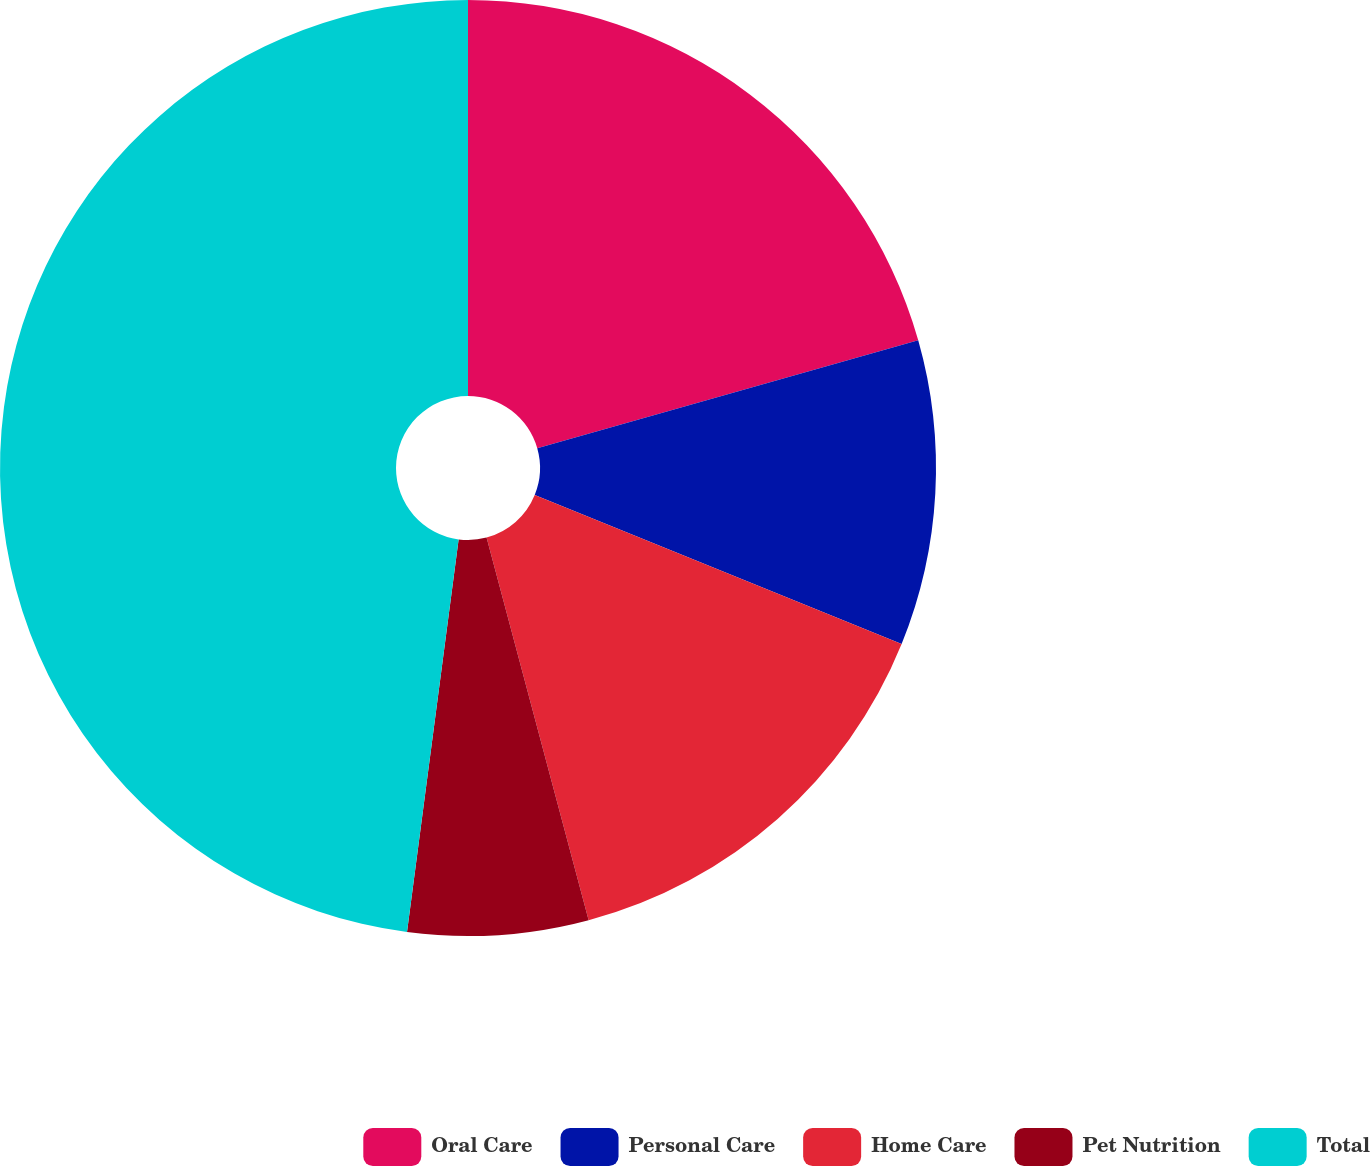Convert chart to OTSL. <chart><loc_0><loc_0><loc_500><loc_500><pie_chart><fcel>Oral Care<fcel>Personal Care<fcel>Home Care<fcel>Pet Nutrition<fcel>Total<nl><fcel>20.6%<fcel>10.54%<fcel>14.71%<fcel>6.23%<fcel>47.92%<nl></chart> 